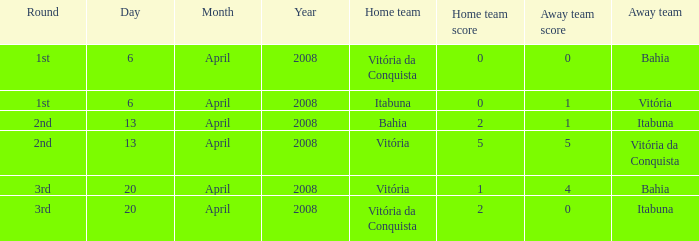On which date was the score 0 - 0? April 6, 2008. 